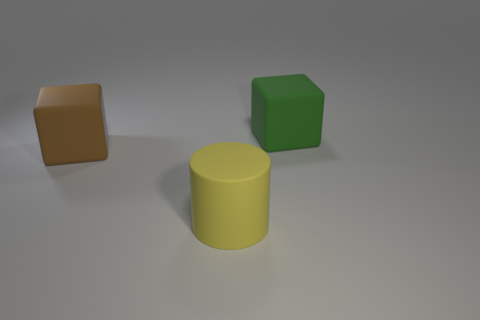Add 3 red matte cylinders. How many objects exist? 6 Subtract all cubes. How many objects are left? 1 Add 2 large brown rubber things. How many large brown rubber things are left? 3 Add 2 big blue rubber cubes. How many big blue rubber cubes exist? 2 Subtract 0 red cylinders. How many objects are left? 3 Subtract all blocks. Subtract all large cylinders. How many objects are left? 0 